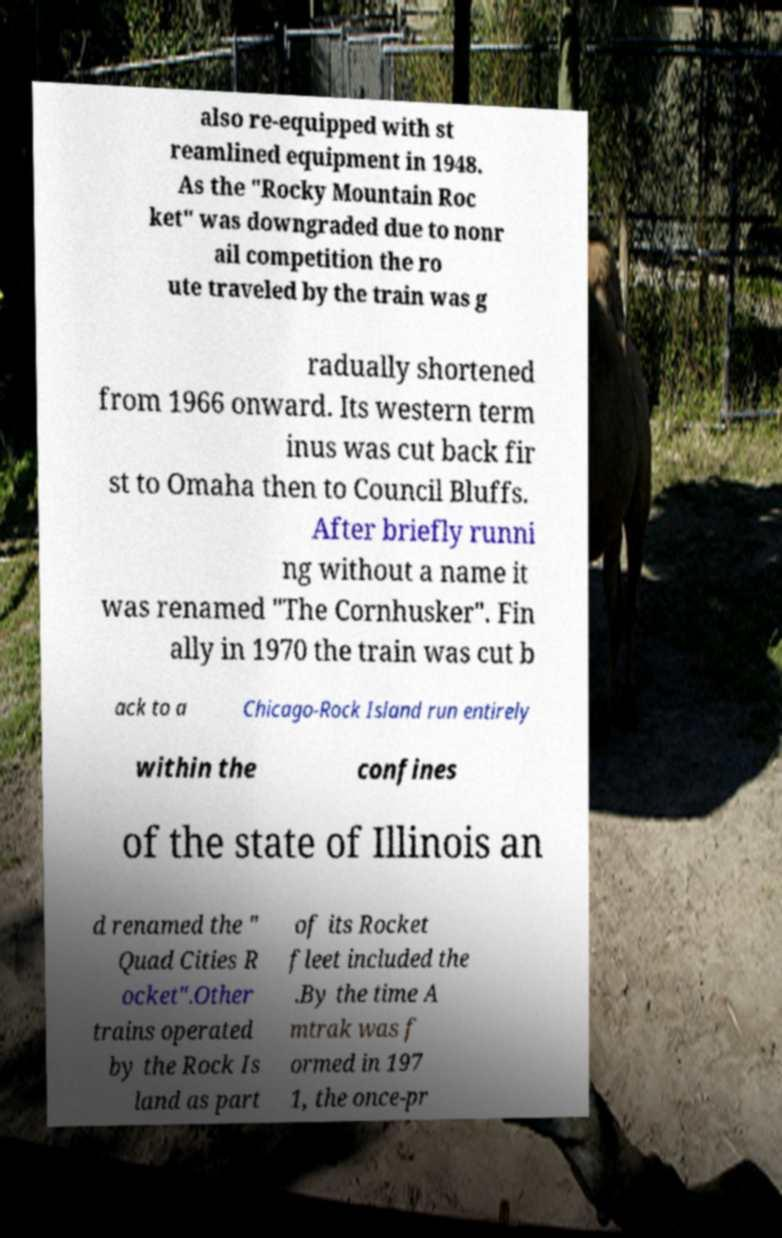Could you assist in decoding the text presented in this image and type it out clearly? also re-equipped with st reamlined equipment in 1948. As the "Rocky Mountain Roc ket" was downgraded due to nonr ail competition the ro ute traveled by the train was g radually shortened from 1966 onward. Its western term inus was cut back fir st to Omaha then to Council Bluffs. After briefly runni ng without a name it was renamed "The Cornhusker". Fin ally in 1970 the train was cut b ack to a Chicago-Rock Island run entirely within the confines of the state of Illinois an d renamed the " Quad Cities R ocket".Other trains operated by the Rock Is land as part of its Rocket fleet included the .By the time A mtrak was f ormed in 197 1, the once-pr 